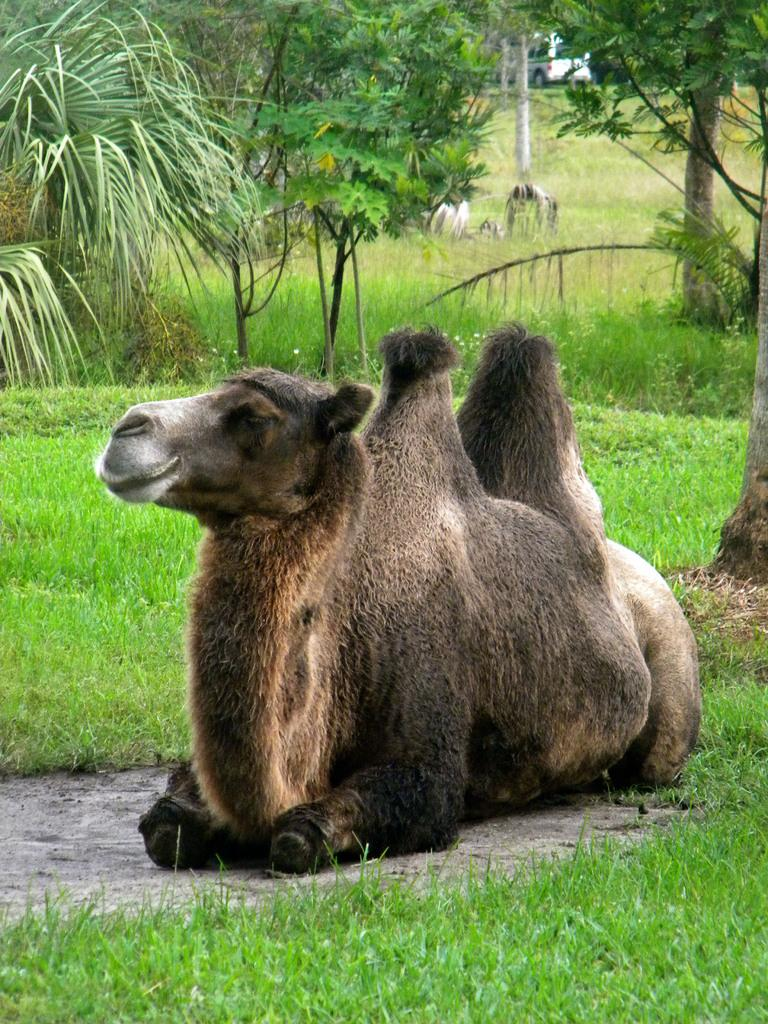What is the animal sitting on in the image? The animal is sitting on the ground in the image. What type of vegetation is around the animal? There is green color grass around the animal. What can be seen in the background of the image? There are trees and a car visible in the background. What type of egg is the animal cooking in the image? There is no egg or cooking activity present in the image. 